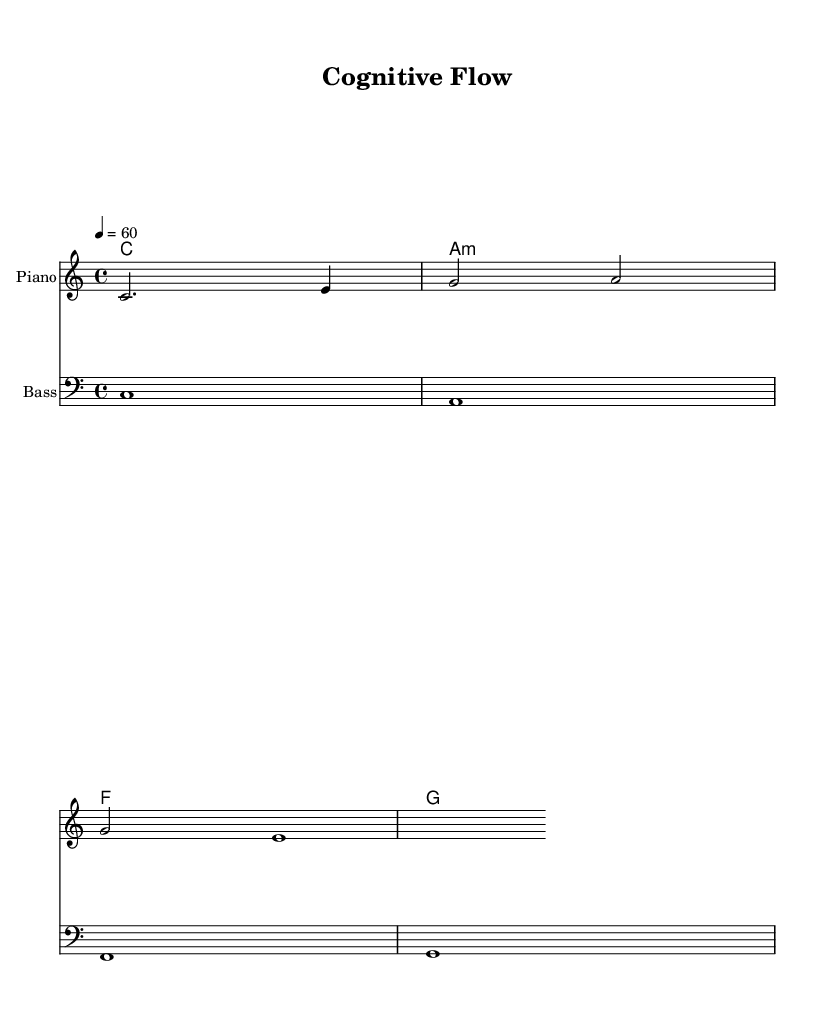What is the key signature of this music? The key signature is C major, which has no sharps or flats.
Answer: C major What is the time signature of the piece? The time signature indicated is 4/4, meaning there are four beats in each measure and a quarter note receives one beat.
Answer: 4/4 What is the tempo marking for this score? The tempo marking indicates a tempo of 60 beats per minute, dictating a slow pace suitable for focus and concentration.
Answer: 60 How many measures are in the melody? The melody consists of three measures based on the visual representation of the notes grouped within the staff.
Answer: 3 What is the primary function of the bass line in this piece? The bass line provides a foundational harmonic structure that supports the melody, anchoring the overall sound without being overly complex.
Answer: Harmonic support What chords are used in the harmony section? The chords displayed include C major, A minor, F major, and G major, which together create a rich harmonic palette common in minimalist ambient music.
Answer: C major, A minor, F major, G major How does the harmonic progression support the focus theme in this piece? The harmonic progression moves primarily through consonant chords, emphasizing stability and calm, which are conducive for focus and problem-solving tasks.
Answer: Consonant chords 